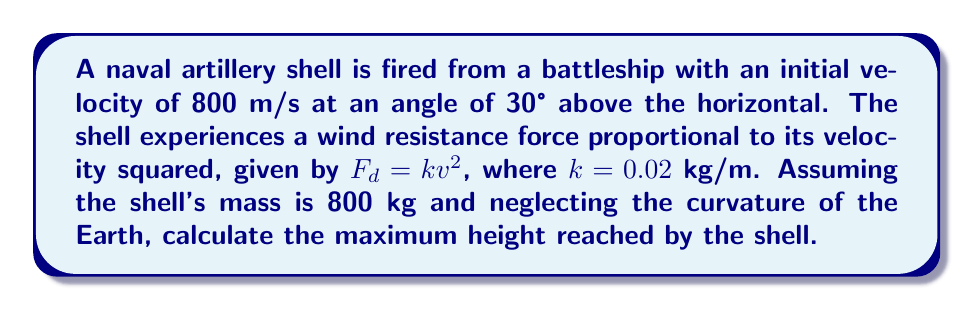What is the answer to this math problem? To solve this problem, we'll use the principles of projectile motion with air resistance. Let's break it down step-by-step:

1) First, we need to set up our equations of motion. In the vertical direction:

   $$\frac{d^2y}{dt^2} = -g - \frac{k}{m}v_y^2$$

   Where $g$ is the acceleration due to gravity (9.8 m/s²), $m$ is the mass of the shell, and $v_y$ is the vertical component of velocity.

2) At the maximum height, the vertical velocity will be zero. So we can use the work-energy theorem to find the maximum height:

   $$\frac{1}{2}mv_0^2\sin^2\theta - mgh_{max} = \int_0^{h_{max}} F_d dy$$

3) The initial vertical velocity $v_0\sin\theta$ is:

   $$v_0\sin\theta = 800 \cdot \sin(30°) = 400 \text{ m/s}$$

4) The right side of the equation represents the work done by air resistance. We can approximate this integral as:

   $$\int_0^{h_{max}} F_d dy \approx \frac{1}{3}kv_0^2\sin^2\theta h_{max}$$

5) Substituting these into our work-energy equation:

   $$\frac{1}{2} \cdot 800 \cdot 400^2 - 800 \cdot 9.8 \cdot h_{max} = \frac{1}{3} \cdot 0.02 \cdot 400^2 \cdot h_{max}$$

6) Simplifying:

   $$64,000,000 - 7,840h_{max} = 1,066.67h_{max}$$

7) Solving for $h_{max}$:

   $$h_{max} = \frac{64,000,000}{7,840 + 1,066.67} \approx 7,190 \text{ meters}$$
Answer: 7,190 meters 